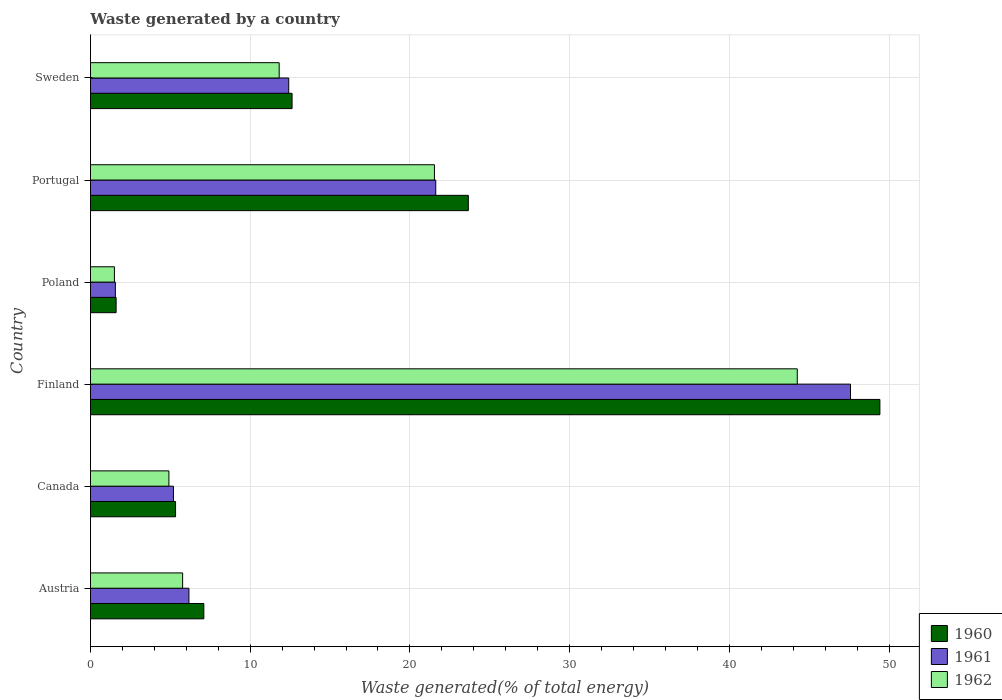How many different coloured bars are there?
Your answer should be compact. 3. Are the number of bars per tick equal to the number of legend labels?
Ensure brevity in your answer.  Yes. Are the number of bars on each tick of the Y-axis equal?
Your response must be concise. Yes. How many bars are there on the 4th tick from the bottom?
Your answer should be very brief. 3. What is the total waste generated in 1962 in Portugal?
Provide a short and direct response. 21.53. Across all countries, what is the maximum total waste generated in 1961?
Give a very brief answer. 47.58. Across all countries, what is the minimum total waste generated in 1960?
Provide a short and direct response. 1.6. In which country was the total waste generated in 1962 minimum?
Your answer should be very brief. Poland. What is the total total waste generated in 1962 in the graph?
Your response must be concise. 89.78. What is the difference between the total waste generated in 1961 in Finland and that in Poland?
Your response must be concise. 46.02. What is the difference between the total waste generated in 1960 in Canada and the total waste generated in 1961 in Finland?
Keep it short and to the point. -42.25. What is the average total waste generated in 1962 per country?
Provide a succinct answer. 14.96. What is the difference between the total waste generated in 1960 and total waste generated in 1962 in Canada?
Keep it short and to the point. 0.42. In how many countries, is the total waste generated in 1961 greater than 42 %?
Your answer should be compact. 1. What is the ratio of the total waste generated in 1961 in Portugal to that in Sweden?
Make the answer very short. 1.74. Is the total waste generated in 1960 in Austria less than that in Finland?
Give a very brief answer. Yes. Is the difference between the total waste generated in 1960 in Poland and Sweden greater than the difference between the total waste generated in 1962 in Poland and Sweden?
Make the answer very short. No. What is the difference between the highest and the second highest total waste generated in 1960?
Provide a succinct answer. 25.77. What is the difference between the highest and the lowest total waste generated in 1961?
Keep it short and to the point. 46.02. What does the 3rd bar from the top in Poland represents?
Provide a succinct answer. 1960. Is it the case that in every country, the sum of the total waste generated in 1961 and total waste generated in 1960 is greater than the total waste generated in 1962?
Make the answer very short. Yes. Are all the bars in the graph horizontal?
Keep it short and to the point. Yes. Are the values on the major ticks of X-axis written in scientific E-notation?
Your answer should be compact. No. Does the graph contain any zero values?
Ensure brevity in your answer.  No. Does the graph contain grids?
Offer a very short reply. Yes. How are the legend labels stacked?
Ensure brevity in your answer.  Vertical. What is the title of the graph?
Offer a terse response. Waste generated by a country. What is the label or title of the X-axis?
Your answer should be compact. Waste generated(% of total energy). What is the label or title of the Y-axis?
Make the answer very short. Country. What is the Waste generated(% of total energy) of 1960 in Austria?
Provide a short and direct response. 7.1. What is the Waste generated(% of total energy) of 1961 in Austria?
Ensure brevity in your answer.  6.16. What is the Waste generated(% of total energy) of 1962 in Austria?
Your answer should be very brief. 5.77. What is the Waste generated(% of total energy) in 1960 in Canada?
Give a very brief answer. 5.33. What is the Waste generated(% of total energy) of 1961 in Canada?
Make the answer very short. 5.19. What is the Waste generated(% of total energy) of 1962 in Canada?
Your answer should be very brief. 4.91. What is the Waste generated(% of total energy) in 1960 in Finland?
Provide a short and direct response. 49.42. What is the Waste generated(% of total energy) in 1961 in Finland?
Your answer should be very brief. 47.58. What is the Waste generated(% of total energy) of 1962 in Finland?
Keep it short and to the point. 44.25. What is the Waste generated(% of total energy) of 1960 in Poland?
Your answer should be compact. 1.6. What is the Waste generated(% of total energy) in 1961 in Poland?
Ensure brevity in your answer.  1.56. What is the Waste generated(% of total energy) of 1962 in Poland?
Your answer should be compact. 1.5. What is the Waste generated(% of total energy) in 1960 in Portugal?
Give a very brief answer. 23.66. What is the Waste generated(% of total energy) of 1961 in Portugal?
Your response must be concise. 21.62. What is the Waste generated(% of total energy) in 1962 in Portugal?
Your response must be concise. 21.53. What is the Waste generated(% of total energy) of 1960 in Sweden?
Ensure brevity in your answer.  12.62. What is the Waste generated(% of total energy) in 1961 in Sweden?
Provide a short and direct response. 12.41. What is the Waste generated(% of total energy) of 1962 in Sweden?
Offer a very short reply. 11.82. Across all countries, what is the maximum Waste generated(% of total energy) in 1960?
Ensure brevity in your answer.  49.42. Across all countries, what is the maximum Waste generated(% of total energy) in 1961?
Keep it short and to the point. 47.58. Across all countries, what is the maximum Waste generated(% of total energy) of 1962?
Give a very brief answer. 44.25. Across all countries, what is the minimum Waste generated(% of total energy) of 1960?
Give a very brief answer. 1.6. Across all countries, what is the minimum Waste generated(% of total energy) in 1961?
Ensure brevity in your answer.  1.56. Across all countries, what is the minimum Waste generated(% of total energy) of 1962?
Ensure brevity in your answer.  1.5. What is the total Waste generated(% of total energy) in 1960 in the graph?
Make the answer very short. 99.73. What is the total Waste generated(% of total energy) of 1961 in the graph?
Provide a succinct answer. 94.53. What is the total Waste generated(% of total energy) of 1962 in the graph?
Provide a succinct answer. 89.78. What is the difference between the Waste generated(% of total energy) in 1960 in Austria and that in Canada?
Make the answer very short. 1.77. What is the difference between the Waste generated(% of total energy) of 1961 in Austria and that in Canada?
Your response must be concise. 0.97. What is the difference between the Waste generated(% of total energy) of 1962 in Austria and that in Canada?
Make the answer very short. 0.86. What is the difference between the Waste generated(% of total energy) in 1960 in Austria and that in Finland?
Give a very brief answer. -42.33. What is the difference between the Waste generated(% of total energy) in 1961 in Austria and that in Finland?
Provide a short and direct response. -41.42. What is the difference between the Waste generated(% of total energy) in 1962 in Austria and that in Finland?
Ensure brevity in your answer.  -38.48. What is the difference between the Waste generated(% of total energy) of 1960 in Austria and that in Poland?
Keep it short and to the point. 5.49. What is the difference between the Waste generated(% of total energy) in 1961 in Austria and that in Poland?
Your answer should be compact. 4.61. What is the difference between the Waste generated(% of total energy) in 1962 in Austria and that in Poland?
Provide a short and direct response. 4.27. What is the difference between the Waste generated(% of total energy) in 1960 in Austria and that in Portugal?
Keep it short and to the point. -16.56. What is the difference between the Waste generated(% of total energy) of 1961 in Austria and that in Portugal?
Give a very brief answer. -15.45. What is the difference between the Waste generated(% of total energy) of 1962 in Austria and that in Portugal?
Your answer should be compact. -15.76. What is the difference between the Waste generated(% of total energy) in 1960 in Austria and that in Sweden?
Your answer should be very brief. -5.52. What is the difference between the Waste generated(% of total energy) in 1961 in Austria and that in Sweden?
Keep it short and to the point. -6.25. What is the difference between the Waste generated(% of total energy) in 1962 in Austria and that in Sweden?
Provide a short and direct response. -6.05. What is the difference between the Waste generated(% of total energy) in 1960 in Canada and that in Finland?
Provide a succinct answer. -44.1. What is the difference between the Waste generated(% of total energy) in 1961 in Canada and that in Finland?
Keep it short and to the point. -42.39. What is the difference between the Waste generated(% of total energy) of 1962 in Canada and that in Finland?
Provide a succinct answer. -39.34. What is the difference between the Waste generated(% of total energy) in 1960 in Canada and that in Poland?
Your response must be concise. 3.72. What is the difference between the Waste generated(% of total energy) in 1961 in Canada and that in Poland?
Offer a very short reply. 3.64. What is the difference between the Waste generated(% of total energy) of 1962 in Canada and that in Poland?
Give a very brief answer. 3.41. What is the difference between the Waste generated(% of total energy) in 1960 in Canada and that in Portugal?
Your answer should be very brief. -18.33. What is the difference between the Waste generated(% of total energy) in 1961 in Canada and that in Portugal?
Your answer should be compact. -16.42. What is the difference between the Waste generated(% of total energy) of 1962 in Canada and that in Portugal?
Keep it short and to the point. -16.62. What is the difference between the Waste generated(% of total energy) in 1960 in Canada and that in Sweden?
Offer a terse response. -7.29. What is the difference between the Waste generated(% of total energy) of 1961 in Canada and that in Sweden?
Offer a very short reply. -7.22. What is the difference between the Waste generated(% of total energy) of 1962 in Canada and that in Sweden?
Ensure brevity in your answer.  -6.9. What is the difference between the Waste generated(% of total energy) in 1960 in Finland and that in Poland?
Ensure brevity in your answer.  47.82. What is the difference between the Waste generated(% of total energy) of 1961 in Finland and that in Poland?
Provide a short and direct response. 46.02. What is the difference between the Waste generated(% of total energy) of 1962 in Finland and that in Poland?
Your response must be concise. 42.75. What is the difference between the Waste generated(% of total energy) of 1960 in Finland and that in Portugal?
Your response must be concise. 25.77. What is the difference between the Waste generated(% of total energy) in 1961 in Finland and that in Portugal?
Give a very brief answer. 25.96. What is the difference between the Waste generated(% of total energy) in 1962 in Finland and that in Portugal?
Provide a succinct answer. 22.72. What is the difference between the Waste generated(% of total energy) of 1960 in Finland and that in Sweden?
Offer a very short reply. 36.8. What is the difference between the Waste generated(% of total energy) in 1961 in Finland and that in Sweden?
Offer a terse response. 35.17. What is the difference between the Waste generated(% of total energy) of 1962 in Finland and that in Sweden?
Ensure brevity in your answer.  32.44. What is the difference between the Waste generated(% of total energy) in 1960 in Poland and that in Portugal?
Offer a very short reply. -22.05. What is the difference between the Waste generated(% of total energy) in 1961 in Poland and that in Portugal?
Keep it short and to the point. -20.06. What is the difference between the Waste generated(% of total energy) in 1962 in Poland and that in Portugal?
Provide a succinct answer. -20.03. What is the difference between the Waste generated(% of total energy) in 1960 in Poland and that in Sweden?
Offer a terse response. -11.02. What is the difference between the Waste generated(% of total energy) of 1961 in Poland and that in Sweden?
Ensure brevity in your answer.  -10.85. What is the difference between the Waste generated(% of total energy) of 1962 in Poland and that in Sweden?
Your answer should be very brief. -10.32. What is the difference between the Waste generated(% of total energy) in 1960 in Portugal and that in Sweden?
Provide a short and direct response. 11.03. What is the difference between the Waste generated(% of total energy) in 1961 in Portugal and that in Sweden?
Provide a short and direct response. 9.2. What is the difference between the Waste generated(% of total energy) in 1962 in Portugal and that in Sweden?
Provide a short and direct response. 9.72. What is the difference between the Waste generated(% of total energy) in 1960 in Austria and the Waste generated(% of total energy) in 1961 in Canada?
Ensure brevity in your answer.  1.9. What is the difference between the Waste generated(% of total energy) of 1960 in Austria and the Waste generated(% of total energy) of 1962 in Canada?
Your answer should be compact. 2.19. What is the difference between the Waste generated(% of total energy) of 1961 in Austria and the Waste generated(% of total energy) of 1962 in Canada?
Your response must be concise. 1.25. What is the difference between the Waste generated(% of total energy) in 1960 in Austria and the Waste generated(% of total energy) in 1961 in Finland?
Your response must be concise. -40.48. What is the difference between the Waste generated(% of total energy) in 1960 in Austria and the Waste generated(% of total energy) in 1962 in Finland?
Offer a very short reply. -37.15. What is the difference between the Waste generated(% of total energy) of 1961 in Austria and the Waste generated(% of total energy) of 1962 in Finland?
Ensure brevity in your answer.  -38.09. What is the difference between the Waste generated(% of total energy) of 1960 in Austria and the Waste generated(% of total energy) of 1961 in Poland?
Offer a very short reply. 5.54. What is the difference between the Waste generated(% of total energy) of 1960 in Austria and the Waste generated(% of total energy) of 1962 in Poland?
Offer a very short reply. 5.6. What is the difference between the Waste generated(% of total energy) in 1961 in Austria and the Waste generated(% of total energy) in 1962 in Poland?
Your response must be concise. 4.67. What is the difference between the Waste generated(% of total energy) of 1960 in Austria and the Waste generated(% of total energy) of 1961 in Portugal?
Your answer should be very brief. -14.52. What is the difference between the Waste generated(% of total energy) of 1960 in Austria and the Waste generated(% of total energy) of 1962 in Portugal?
Your response must be concise. -14.44. What is the difference between the Waste generated(% of total energy) of 1961 in Austria and the Waste generated(% of total energy) of 1962 in Portugal?
Ensure brevity in your answer.  -15.37. What is the difference between the Waste generated(% of total energy) in 1960 in Austria and the Waste generated(% of total energy) in 1961 in Sweden?
Keep it short and to the point. -5.32. What is the difference between the Waste generated(% of total energy) of 1960 in Austria and the Waste generated(% of total energy) of 1962 in Sweden?
Ensure brevity in your answer.  -4.72. What is the difference between the Waste generated(% of total energy) in 1961 in Austria and the Waste generated(% of total energy) in 1962 in Sweden?
Provide a succinct answer. -5.65. What is the difference between the Waste generated(% of total energy) in 1960 in Canada and the Waste generated(% of total energy) in 1961 in Finland?
Your answer should be very brief. -42.25. What is the difference between the Waste generated(% of total energy) of 1960 in Canada and the Waste generated(% of total energy) of 1962 in Finland?
Keep it short and to the point. -38.92. What is the difference between the Waste generated(% of total energy) of 1961 in Canada and the Waste generated(% of total energy) of 1962 in Finland?
Your answer should be compact. -39.06. What is the difference between the Waste generated(% of total energy) of 1960 in Canada and the Waste generated(% of total energy) of 1961 in Poland?
Offer a terse response. 3.77. What is the difference between the Waste generated(% of total energy) of 1960 in Canada and the Waste generated(% of total energy) of 1962 in Poland?
Provide a short and direct response. 3.83. What is the difference between the Waste generated(% of total energy) of 1961 in Canada and the Waste generated(% of total energy) of 1962 in Poland?
Offer a very short reply. 3.7. What is the difference between the Waste generated(% of total energy) in 1960 in Canada and the Waste generated(% of total energy) in 1961 in Portugal?
Make the answer very short. -16.29. What is the difference between the Waste generated(% of total energy) in 1960 in Canada and the Waste generated(% of total energy) in 1962 in Portugal?
Provide a short and direct response. -16.21. What is the difference between the Waste generated(% of total energy) of 1961 in Canada and the Waste generated(% of total energy) of 1962 in Portugal?
Provide a short and direct response. -16.34. What is the difference between the Waste generated(% of total energy) of 1960 in Canada and the Waste generated(% of total energy) of 1961 in Sweden?
Your answer should be very brief. -7.08. What is the difference between the Waste generated(% of total energy) in 1960 in Canada and the Waste generated(% of total energy) in 1962 in Sweden?
Provide a succinct answer. -6.49. What is the difference between the Waste generated(% of total energy) in 1961 in Canada and the Waste generated(% of total energy) in 1962 in Sweden?
Offer a very short reply. -6.62. What is the difference between the Waste generated(% of total energy) in 1960 in Finland and the Waste generated(% of total energy) in 1961 in Poland?
Your response must be concise. 47.86. What is the difference between the Waste generated(% of total energy) in 1960 in Finland and the Waste generated(% of total energy) in 1962 in Poland?
Your response must be concise. 47.92. What is the difference between the Waste generated(% of total energy) of 1961 in Finland and the Waste generated(% of total energy) of 1962 in Poland?
Provide a succinct answer. 46.08. What is the difference between the Waste generated(% of total energy) of 1960 in Finland and the Waste generated(% of total energy) of 1961 in Portugal?
Offer a very short reply. 27.81. What is the difference between the Waste generated(% of total energy) of 1960 in Finland and the Waste generated(% of total energy) of 1962 in Portugal?
Your response must be concise. 27.89. What is the difference between the Waste generated(% of total energy) in 1961 in Finland and the Waste generated(% of total energy) in 1962 in Portugal?
Your answer should be compact. 26.05. What is the difference between the Waste generated(% of total energy) in 1960 in Finland and the Waste generated(% of total energy) in 1961 in Sweden?
Offer a very short reply. 37.01. What is the difference between the Waste generated(% of total energy) of 1960 in Finland and the Waste generated(% of total energy) of 1962 in Sweden?
Provide a succinct answer. 37.61. What is the difference between the Waste generated(% of total energy) in 1961 in Finland and the Waste generated(% of total energy) in 1962 in Sweden?
Offer a terse response. 35.77. What is the difference between the Waste generated(% of total energy) in 1960 in Poland and the Waste generated(% of total energy) in 1961 in Portugal?
Give a very brief answer. -20.01. What is the difference between the Waste generated(% of total energy) in 1960 in Poland and the Waste generated(% of total energy) in 1962 in Portugal?
Offer a terse response. -19.93. What is the difference between the Waste generated(% of total energy) in 1961 in Poland and the Waste generated(% of total energy) in 1962 in Portugal?
Ensure brevity in your answer.  -19.98. What is the difference between the Waste generated(% of total energy) in 1960 in Poland and the Waste generated(% of total energy) in 1961 in Sweden?
Offer a terse response. -10.81. What is the difference between the Waste generated(% of total energy) in 1960 in Poland and the Waste generated(% of total energy) in 1962 in Sweden?
Your response must be concise. -10.21. What is the difference between the Waste generated(% of total energy) of 1961 in Poland and the Waste generated(% of total energy) of 1962 in Sweden?
Keep it short and to the point. -10.26. What is the difference between the Waste generated(% of total energy) of 1960 in Portugal and the Waste generated(% of total energy) of 1961 in Sweden?
Offer a terse response. 11.24. What is the difference between the Waste generated(% of total energy) in 1960 in Portugal and the Waste generated(% of total energy) in 1962 in Sweden?
Make the answer very short. 11.84. What is the difference between the Waste generated(% of total energy) of 1961 in Portugal and the Waste generated(% of total energy) of 1962 in Sweden?
Keep it short and to the point. 9.8. What is the average Waste generated(% of total energy) of 1960 per country?
Give a very brief answer. 16.62. What is the average Waste generated(% of total energy) of 1961 per country?
Ensure brevity in your answer.  15.75. What is the average Waste generated(% of total energy) in 1962 per country?
Keep it short and to the point. 14.96. What is the difference between the Waste generated(% of total energy) in 1960 and Waste generated(% of total energy) in 1961 in Austria?
Ensure brevity in your answer.  0.93. What is the difference between the Waste generated(% of total energy) of 1960 and Waste generated(% of total energy) of 1962 in Austria?
Provide a succinct answer. 1.33. What is the difference between the Waste generated(% of total energy) in 1961 and Waste generated(% of total energy) in 1962 in Austria?
Your answer should be very brief. 0.4. What is the difference between the Waste generated(% of total energy) in 1960 and Waste generated(% of total energy) in 1961 in Canada?
Give a very brief answer. 0.13. What is the difference between the Waste generated(% of total energy) of 1960 and Waste generated(% of total energy) of 1962 in Canada?
Ensure brevity in your answer.  0.42. What is the difference between the Waste generated(% of total energy) of 1961 and Waste generated(% of total energy) of 1962 in Canada?
Offer a very short reply. 0.28. What is the difference between the Waste generated(% of total energy) in 1960 and Waste generated(% of total energy) in 1961 in Finland?
Your answer should be compact. 1.84. What is the difference between the Waste generated(% of total energy) of 1960 and Waste generated(% of total energy) of 1962 in Finland?
Offer a terse response. 5.17. What is the difference between the Waste generated(% of total energy) in 1961 and Waste generated(% of total energy) in 1962 in Finland?
Keep it short and to the point. 3.33. What is the difference between the Waste generated(% of total energy) of 1960 and Waste generated(% of total energy) of 1961 in Poland?
Offer a terse response. 0.05. What is the difference between the Waste generated(% of total energy) in 1960 and Waste generated(% of total energy) in 1962 in Poland?
Make the answer very short. 0.11. What is the difference between the Waste generated(% of total energy) of 1961 and Waste generated(% of total energy) of 1962 in Poland?
Your answer should be compact. 0.06. What is the difference between the Waste generated(% of total energy) of 1960 and Waste generated(% of total energy) of 1961 in Portugal?
Keep it short and to the point. 2.04. What is the difference between the Waste generated(% of total energy) of 1960 and Waste generated(% of total energy) of 1962 in Portugal?
Your response must be concise. 2.12. What is the difference between the Waste generated(% of total energy) in 1961 and Waste generated(% of total energy) in 1962 in Portugal?
Offer a very short reply. 0.08. What is the difference between the Waste generated(% of total energy) in 1960 and Waste generated(% of total energy) in 1961 in Sweden?
Provide a short and direct response. 0.21. What is the difference between the Waste generated(% of total energy) of 1960 and Waste generated(% of total energy) of 1962 in Sweden?
Your response must be concise. 0.81. What is the difference between the Waste generated(% of total energy) of 1961 and Waste generated(% of total energy) of 1962 in Sweden?
Keep it short and to the point. 0.6. What is the ratio of the Waste generated(% of total energy) of 1960 in Austria to that in Canada?
Your response must be concise. 1.33. What is the ratio of the Waste generated(% of total energy) of 1961 in Austria to that in Canada?
Keep it short and to the point. 1.19. What is the ratio of the Waste generated(% of total energy) in 1962 in Austria to that in Canada?
Ensure brevity in your answer.  1.17. What is the ratio of the Waste generated(% of total energy) of 1960 in Austria to that in Finland?
Offer a very short reply. 0.14. What is the ratio of the Waste generated(% of total energy) in 1961 in Austria to that in Finland?
Your answer should be very brief. 0.13. What is the ratio of the Waste generated(% of total energy) of 1962 in Austria to that in Finland?
Provide a short and direct response. 0.13. What is the ratio of the Waste generated(% of total energy) in 1960 in Austria to that in Poland?
Your response must be concise. 4.42. What is the ratio of the Waste generated(% of total energy) of 1961 in Austria to that in Poland?
Ensure brevity in your answer.  3.96. What is the ratio of the Waste generated(% of total energy) in 1962 in Austria to that in Poland?
Keep it short and to the point. 3.85. What is the ratio of the Waste generated(% of total energy) in 1960 in Austria to that in Portugal?
Your answer should be very brief. 0.3. What is the ratio of the Waste generated(% of total energy) in 1961 in Austria to that in Portugal?
Provide a succinct answer. 0.29. What is the ratio of the Waste generated(% of total energy) of 1962 in Austria to that in Portugal?
Give a very brief answer. 0.27. What is the ratio of the Waste generated(% of total energy) in 1960 in Austria to that in Sweden?
Your answer should be very brief. 0.56. What is the ratio of the Waste generated(% of total energy) in 1961 in Austria to that in Sweden?
Ensure brevity in your answer.  0.5. What is the ratio of the Waste generated(% of total energy) of 1962 in Austria to that in Sweden?
Make the answer very short. 0.49. What is the ratio of the Waste generated(% of total energy) of 1960 in Canada to that in Finland?
Provide a succinct answer. 0.11. What is the ratio of the Waste generated(% of total energy) of 1961 in Canada to that in Finland?
Provide a short and direct response. 0.11. What is the ratio of the Waste generated(% of total energy) of 1962 in Canada to that in Finland?
Provide a short and direct response. 0.11. What is the ratio of the Waste generated(% of total energy) in 1960 in Canada to that in Poland?
Provide a short and direct response. 3.32. What is the ratio of the Waste generated(% of total energy) in 1961 in Canada to that in Poland?
Keep it short and to the point. 3.33. What is the ratio of the Waste generated(% of total energy) in 1962 in Canada to that in Poland?
Ensure brevity in your answer.  3.28. What is the ratio of the Waste generated(% of total energy) of 1960 in Canada to that in Portugal?
Keep it short and to the point. 0.23. What is the ratio of the Waste generated(% of total energy) of 1961 in Canada to that in Portugal?
Give a very brief answer. 0.24. What is the ratio of the Waste generated(% of total energy) in 1962 in Canada to that in Portugal?
Your answer should be very brief. 0.23. What is the ratio of the Waste generated(% of total energy) in 1960 in Canada to that in Sweden?
Provide a short and direct response. 0.42. What is the ratio of the Waste generated(% of total energy) in 1961 in Canada to that in Sweden?
Your answer should be compact. 0.42. What is the ratio of the Waste generated(% of total energy) in 1962 in Canada to that in Sweden?
Your answer should be very brief. 0.42. What is the ratio of the Waste generated(% of total energy) in 1960 in Finland to that in Poland?
Ensure brevity in your answer.  30.8. What is the ratio of the Waste generated(% of total energy) in 1961 in Finland to that in Poland?
Your answer should be compact. 30.53. What is the ratio of the Waste generated(% of total energy) of 1962 in Finland to that in Poland?
Give a very brief answer. 29.52. What is the ratio of the Waste generated(% of total energy) in 1960 in Finland to that in Portugal?
Offer a very short reply. 2.09. What is the ratio of the Waste generated(% of total energy) in 1961 in Finland to that in Portugal?
Offer a very short reply. 2.2. What is the ratio of the Waste generated(% of total energy) in 1962 in Finland to that in Portugal?
Ensure brevity in your answer.  2.05. What is the ratio of the Waste generated(% of total energy) of 1960 in Finland to that in Sweden?
Make the answer very short. 3.92. What is the ratio of the Waste generated(% of total energy) in 1961 in Finland to that in Sweden?
Your answer should be very brief. 3.83. What is the ratio of the Waste generated(% of total energy) in 1962 in Finland to that in Sweden?
Your answer should be compact. 3.75. What is the ratio of the Waste generated(% of total energy) in 1960 in Poland to that in Portugal?
Provide a succinct answer. 0.07. What is the ratio of the Waste generated(% of total energy) in 1961 in Poland to that in Portugal?
Ensure brevity in your answer.  0.07. What is the ratio of the Waste generated(% of total energy) in 1962 in Poland to that in Portugal?
Make the answer very short. 0.07. What is the ratio of the Waste generated(% of total energy) of 1960 in Poland to that in Sweden?
Offer a very short reply. 0.13. What is the ratio of the Waste generated(% of total energy) in 1961 in Poland to that in Sweden?
Your answer should be compact. 0.13. What is the ratio of the Waste generated(% of total energy) of 1962 in Poland to that in Sweden?
Provide a succinct answer. 0.13. What is the ratio of the Waste generated(% of total energy) of 1960 in Portugal to that in Sweden?
Give a very brief answer. 1.87. What is the ratio of the Waste generated(% of total energy) in 1961 in Portugal to that in Sweden?
Your answer should be compact. 1.74. What is the ratio of the Waste generated(% of total energy) of 1962 in Portugal to that in Sweden?
Provide a short and direct response. 1.82. What is the difference between the highest and the second highest Waste generated(% of total energy) in 1960?
Offer a terse response. 25.77. What is the difference between the highest and the second highest Waste generated(% of total energy) of 1961?
Offer a very short reply. 25.96. What is the difference between the highest and the second highest Waste generated(% of total energy) in 1962?
Give a very brief answer. 22.72. What is the difference between the highest and the lowest Waste generated(% of total energy) of 1960?
Provide a succinct answer. 47.82. What is the difference between the highest and the lowest Waste generated(% of total energy) of 1961?
Provide a short and direct response. 46.02. What is the difference between the highest and the lowest Waste generated(% of total energy) in 1962?
Your answer should be compact. 42.75. 